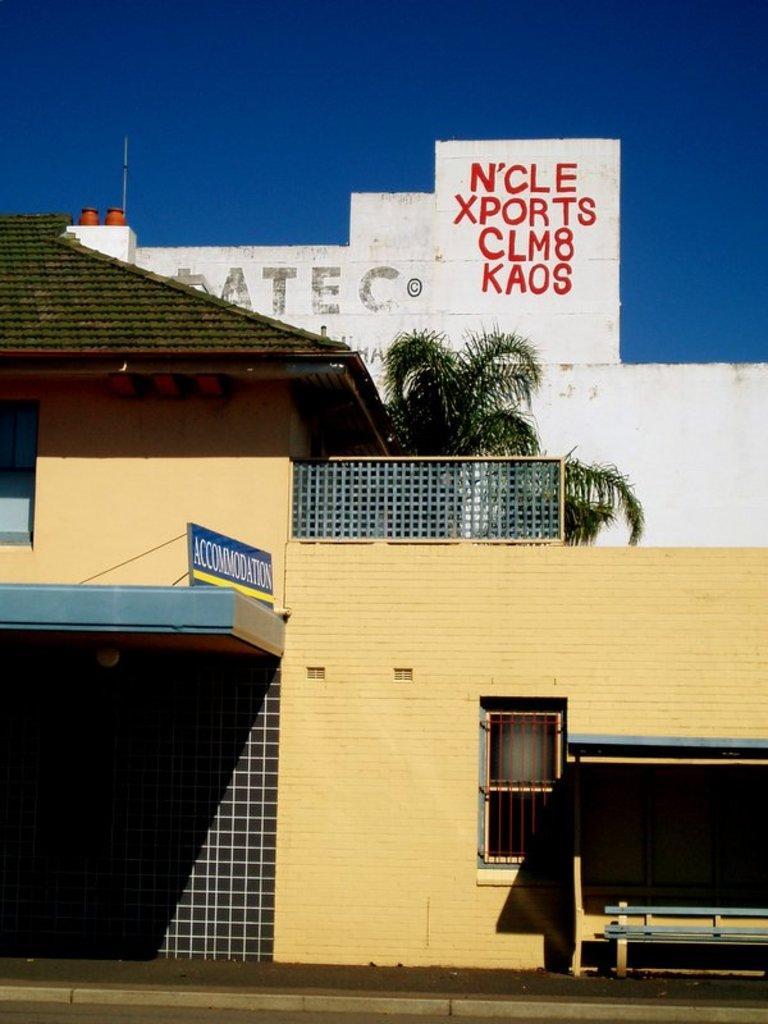Could you give a brief overview of what you see in this image? In this image we can see some houses, tree and top of the image there is clear sky. 